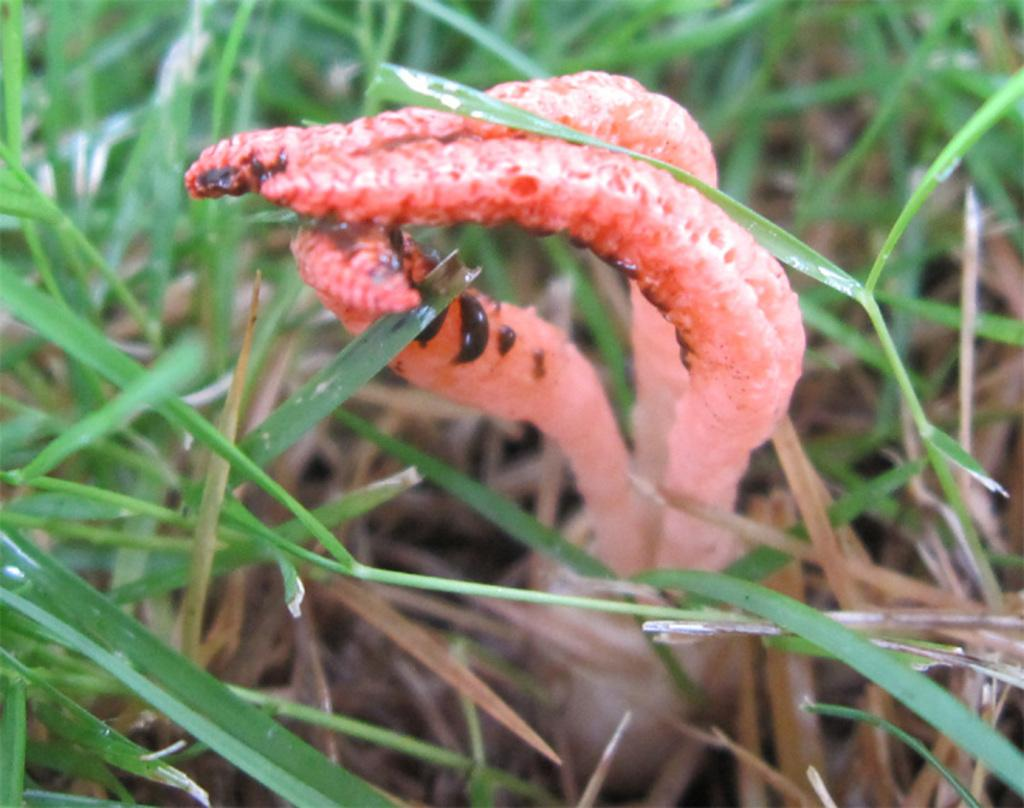What is the main subject in the center of the image? There is a plant in the center of the image. What type of vegetation can be seen in the background of the image? There is grass visible in the background of the image. How does the plant turn around in the image? The plant does not turn around in the image; it is stationary and not capable of movement. 